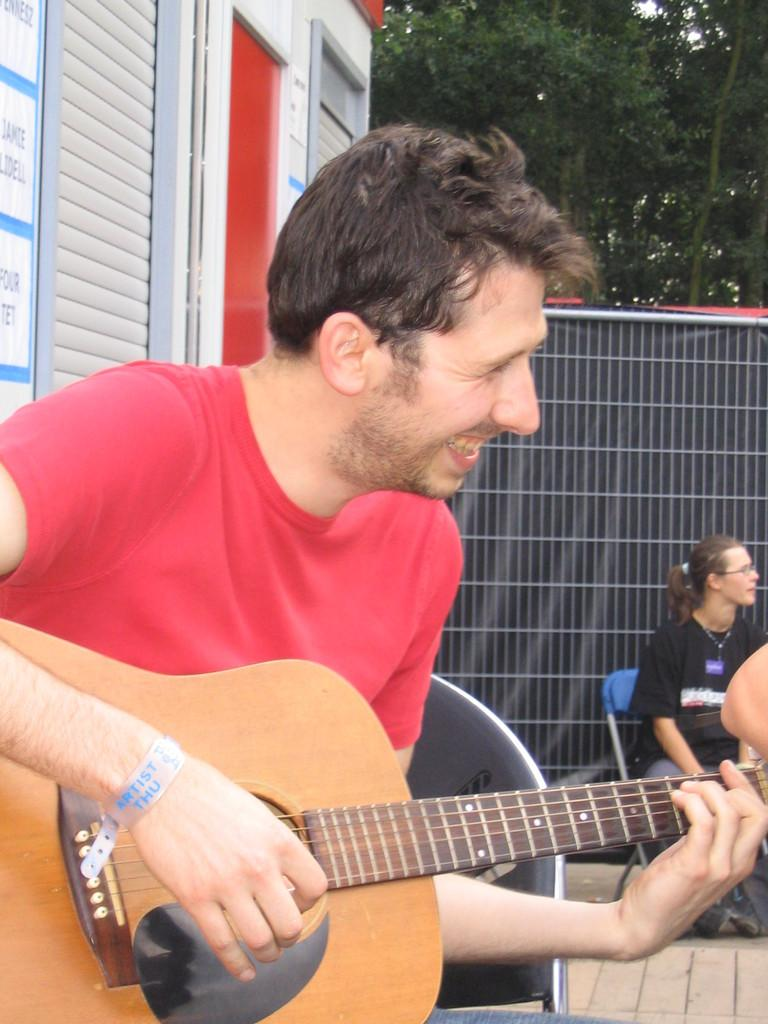What is the man in the image doing? The man is playing a guitar in the image. What is the man's facial expression? The man is smiling in the image. Who else is present in the image? There is a woman in the image. What is the woman doing? The woman is sitting on a chair in the image. What can be seen beneath the people in the image? There is a floor visible in the image. What type of vegetation can be seen in the image? There are trees in the image. What type of seed is the man planting in the image? There is no seed or planting activity present in the image; the man is playing a guitar. What kind of pies is the woman baking in the image? There is no baking or pies present in the image; the woman is sitting on a chair. 